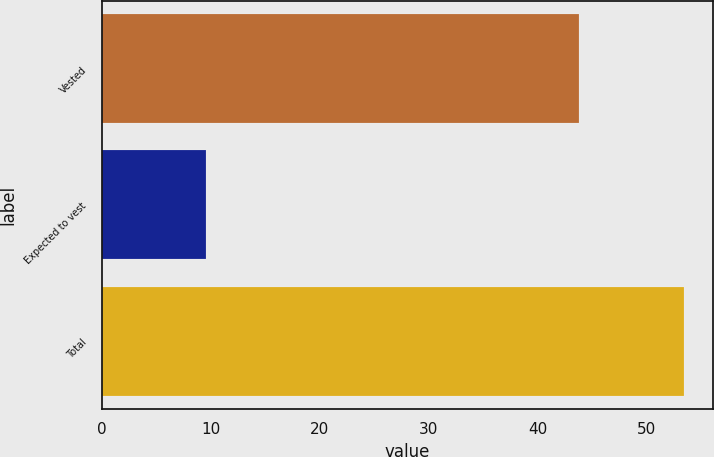<chart> <loc_0><loc_0><loc_500><loc_500><bar_chart><fcel>Vested<fcel>Expected to vest<fcel>Total<nl><fcel>43.8<fcel>9.6<fcel>53.4<nl></chart> 